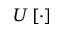Convert formula to latex. <formula><loc_0><loc_0><loc_500><loc_500>U \left [ \cdot \right ]</formula> 